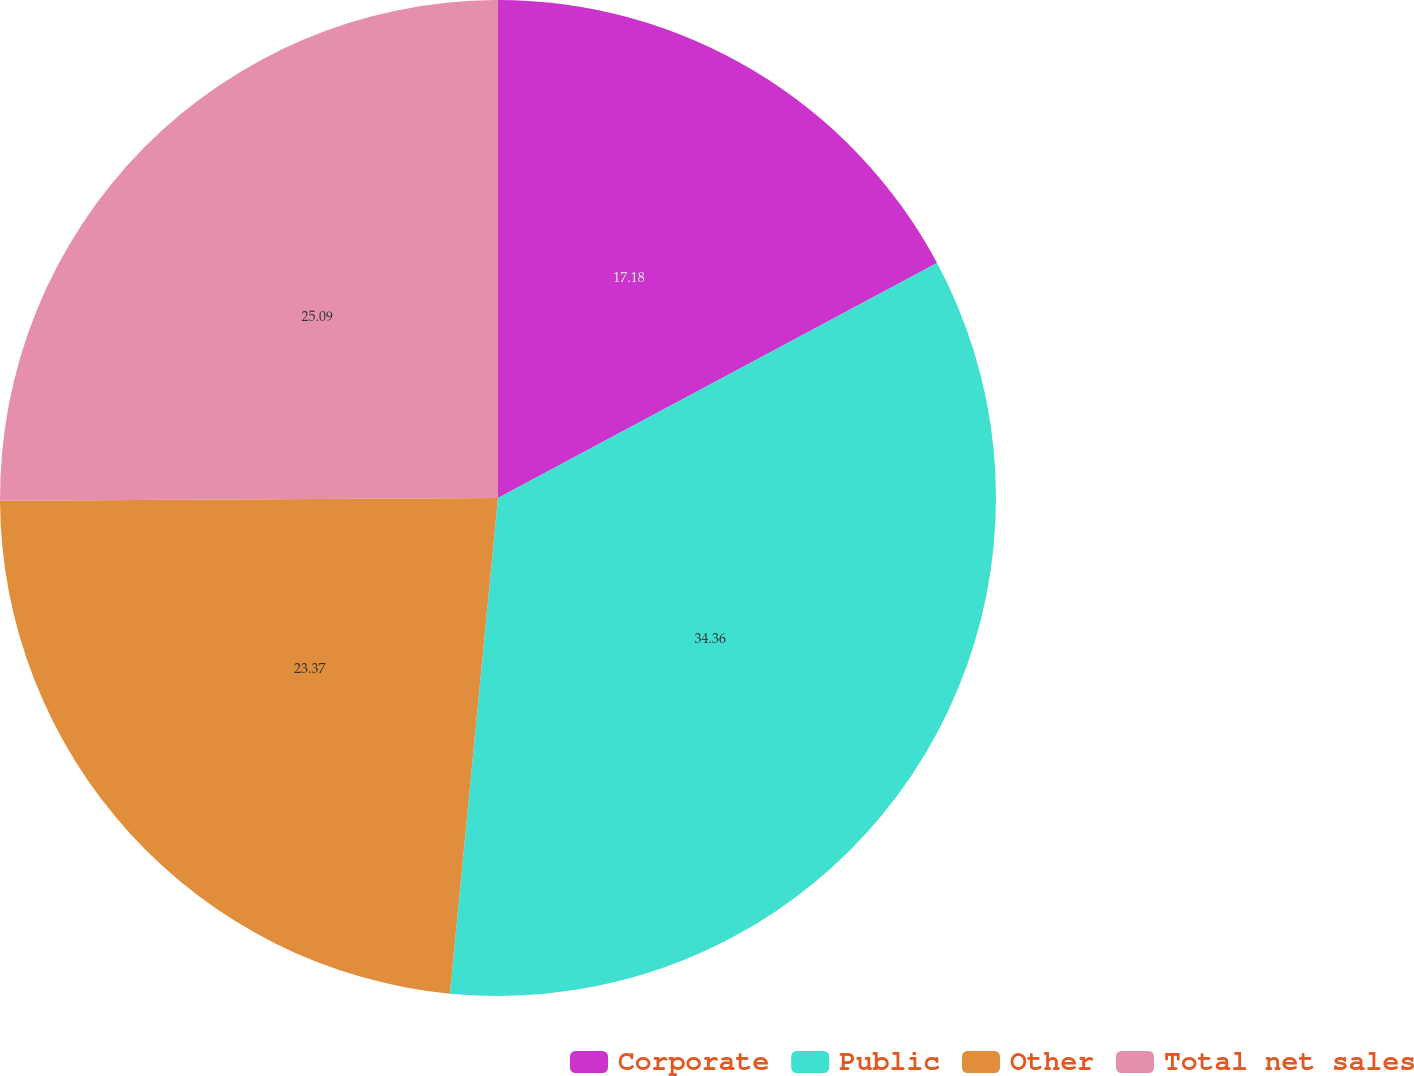Convert chart to OTSL. <chart><loc_0><loc_0><loc_500><loc_500><pie_chart><fcel>Corporate<fcel>Public<fcel>Other<fcel>Total net sales<nl><fcel>17.18%<fcel>34.36%<fcel>23.37%<fcel>25.09%<nl></chart> 